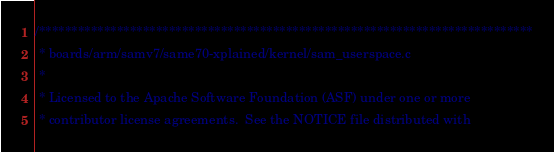Convert code to text. <code><loc_0><loc_0><loc_500><loc_500><_C_>/****************************************************************************
 * boards/arm/samv7/same70-xplained/kernel/sam_userspace.c
 *
 * Licensed to the Apache Software Foundation (ASF) under one or more
 * contributor license agreements.  See the NOTICE file distributed with</code> 